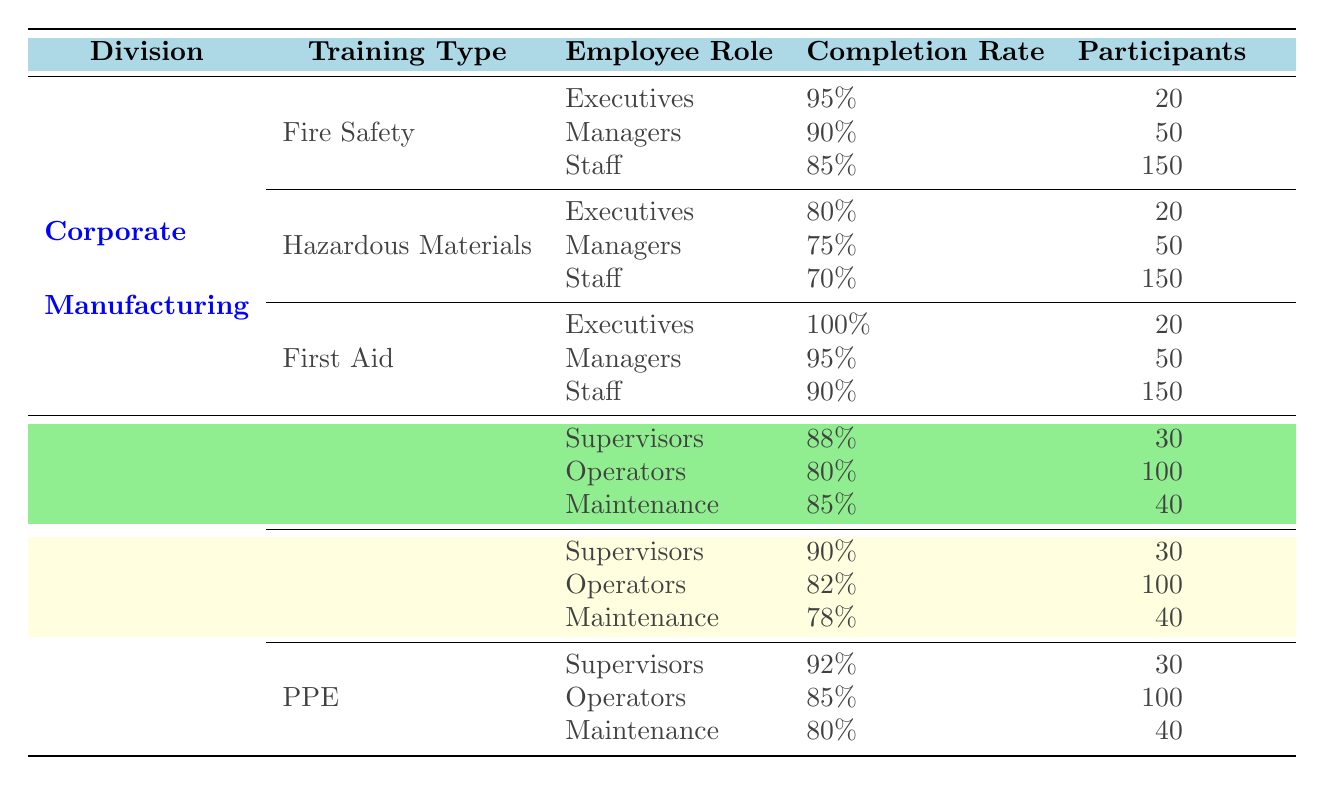What is the completion rate for Executives in First Aid training? According to the table, the completion rate for Executives in First Aid training is listed directly under that section. It shows as 100%.
Answer: 100% What is the total number of participants in Fire Safety training across all employee roles in the Corporate division? To find the total participants in Fire Safety training, sum the participants for each role: Executives (20) + Managers (50) + Staff (150) = 220 participants.
Answer: 220 Which training type has the lowest completion rate for the Staff role in the Corporate division? By comparing the completion rates for Staff across different training types in the Corporate division, we see Fire Safety (85%), Hazardous Materials (70%), and First Aid (90%). The lowest rate is 70% for Hazardous Materials.
Answer: Hazardous Materials Do all Supervisors in the Manufacturing division have a completion rate above 85%? Looking at the table, the completion rates for Supervisors in Manufacturing training types are: Machine Safety (88%), Ergonomics (90%), and PPE (92%). All are above 85%, confirming the statement is true.
Answer: Yes What is the average completion rate for Staff in the Corporate division? For Staff in Corporate training types, the completion rates are: Fire Safety (85%), Hazardous Materials (70%), and First Aid (90%). To find the average, sum the rates (85 + 70 + 90 = 245) and divide by 3, resulting in an average of 245/3 = 81.67%.
Answer: 81.67% What is the highest completion rate among Operators in the Manufacturing division? The completion rates for Operators in the training types are: Machine Safety (80%), Ergonomics (82%), and PPE (85%). The highest completion rate is 85% for PPE training.
Answer: 85% Is the completion rate for Managers in Fire Safety higher than that of Supervisors in Machine Safety? The completion rate for Managers in Fire Safety is 90%, while for Supervisors in Machine Safety, it is 88%. Since 90% is greater than 88%, the statement is true.
Answer: Yes What is the difference in completion rates between the best and worst training type for Staff in the Corporate division? The best completion rate for Staff is 90% in First Aid, and the worst is 70% in Hazardous Materials. The difference is 90% - 70% = 20%.
Answer: 20% 